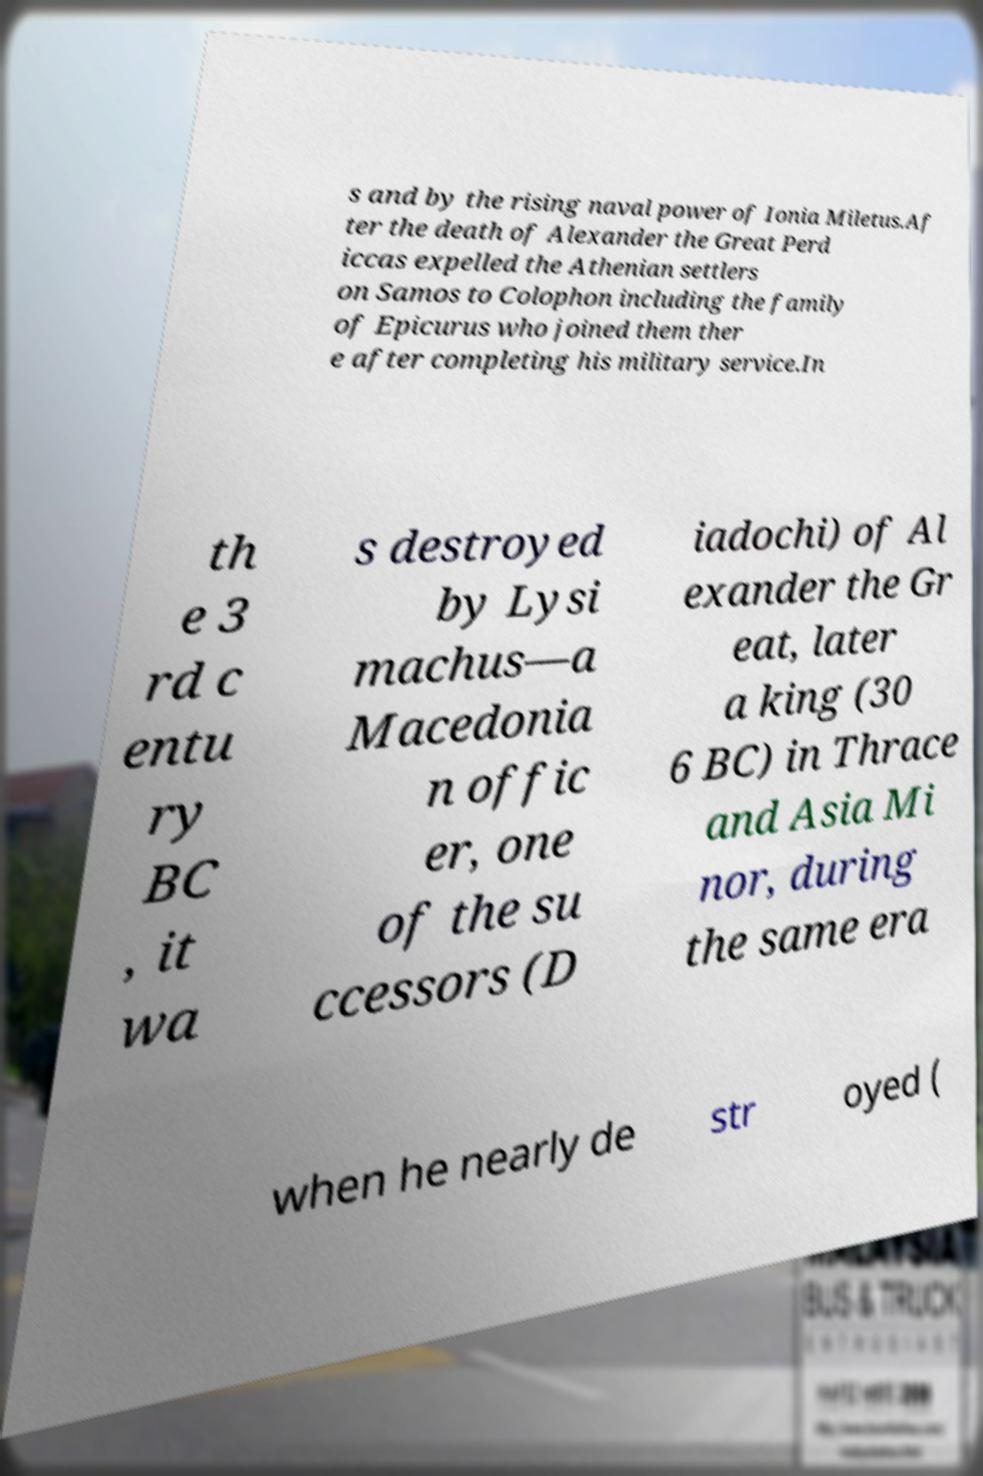Can you accurately transcribe the text from the provided image for me? s and by the rising naval power of Ionia Miletus.Af ter the death of Alexander the Great Perd iccas expelled the Athenian settlers on Samos to Colophon including the family of Epicurus who joined them ther e after completing his military service.In th e 3 rd c entu ry BC , it wa s destroyed by Lysi machus—a Macedonia n offic er, one of the su ccessors (D iadochi) of Al exander the Gr eat, later a king (30 6 BC) in Thrace and Asia Mi nor, during the same era when he nearly de str oyed ( 